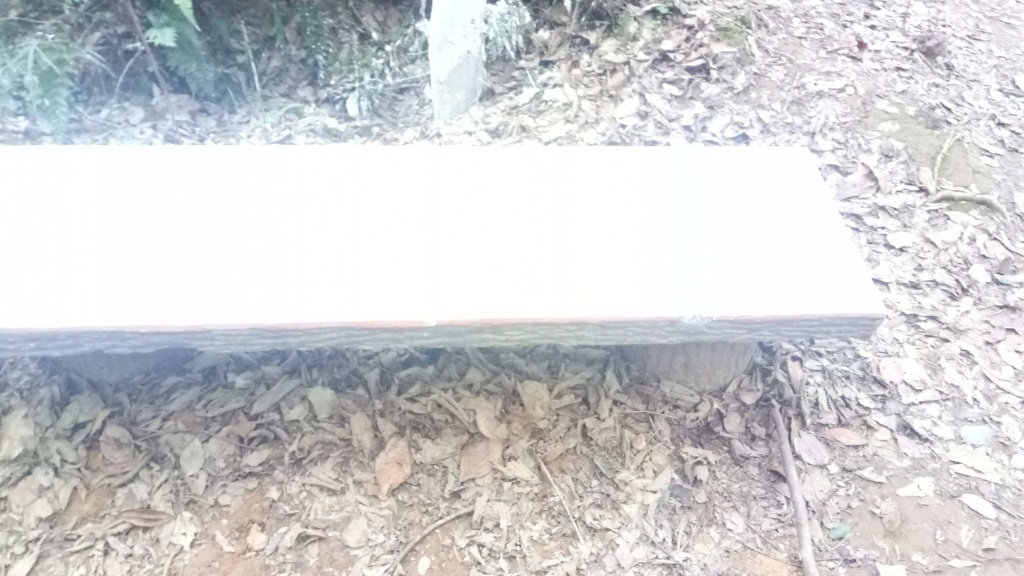Can you tell what time of day this photo was taken? It is difficult to determine the exact time of day with precision, but considering the angle and intensity of the shadows cast by the bench and surrounding foliage, it would suggest that the photo was taken in the late morning or early afternoon. What season do you think is depicted in this image? The presence of numerous dry leaves on the ground and the lack of green foliage suggest that it could be late autumn. The overall appearance of the environment does not indicate the lushness of spring or summer, nor the heavy snow or barren trees typically associated with winter. 